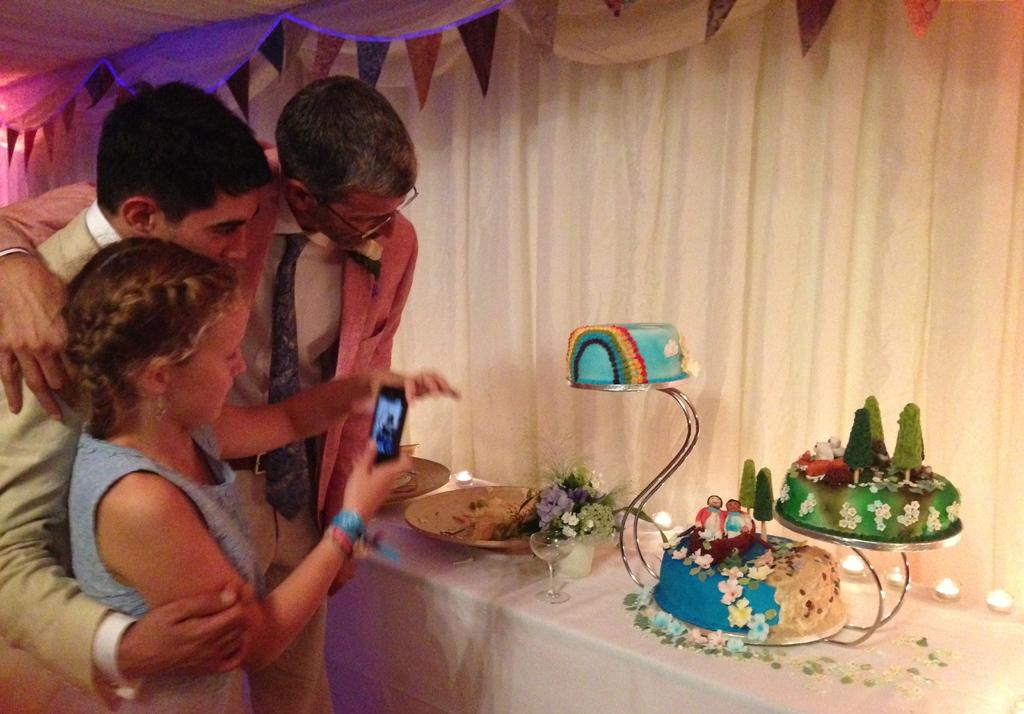How many people can be seen in the image? There are people in the image, but the exact number is not specified. What is covering the window in the image? There is a curtain in the image. What national symbols are present in the image? There are flags in the image. What type of furniture is in the image? There is a table in the image. What type of food is visible in the image? There are cakes in the image. What items might be used for serving or eating in the image? There are plates and glasses in the image. What type of decorative elements are present in the image? There are flowers in the image. What objects are present in the image? There are objects in the image, but the specifics are not mentioned. What is a girl holding in the image? A girl is holding a mobile in the image. What grade is the girl in the image? There is no information about the girl's grade in the image. What type of string is used to hang the flags in the image? There is no information about the type of string used to hang the flags in the image. What type of pump is visible in the image? There is no pump present in the image. 